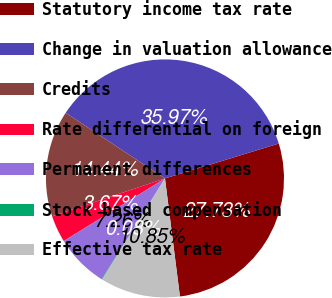<chart> <loc_0><loc_0><loc_500><loc_500><pie_chart><fcel>Statutory income tax rate<fcel>Change in valuation allowance<fcel>Credits<fcel>Rate differential on foreign<fcel>Permanent differences<fcel>Stock based compensation<fcel>Effective tax rate<nl><fcel>27.73%<fcel>35.97%<fcel>14.44%<fcel>3.67%<fcel>7.26%<fcel>0.08%<fcel>10.85%<nl></chart> 